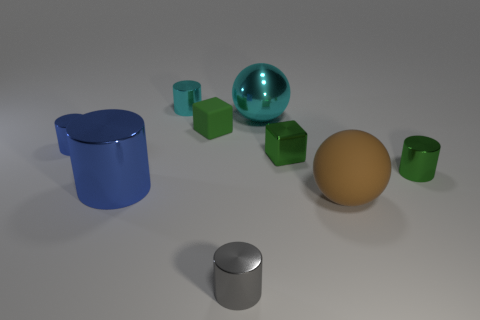Does the small metal cube have the same color as the tiny matte thing? yes 